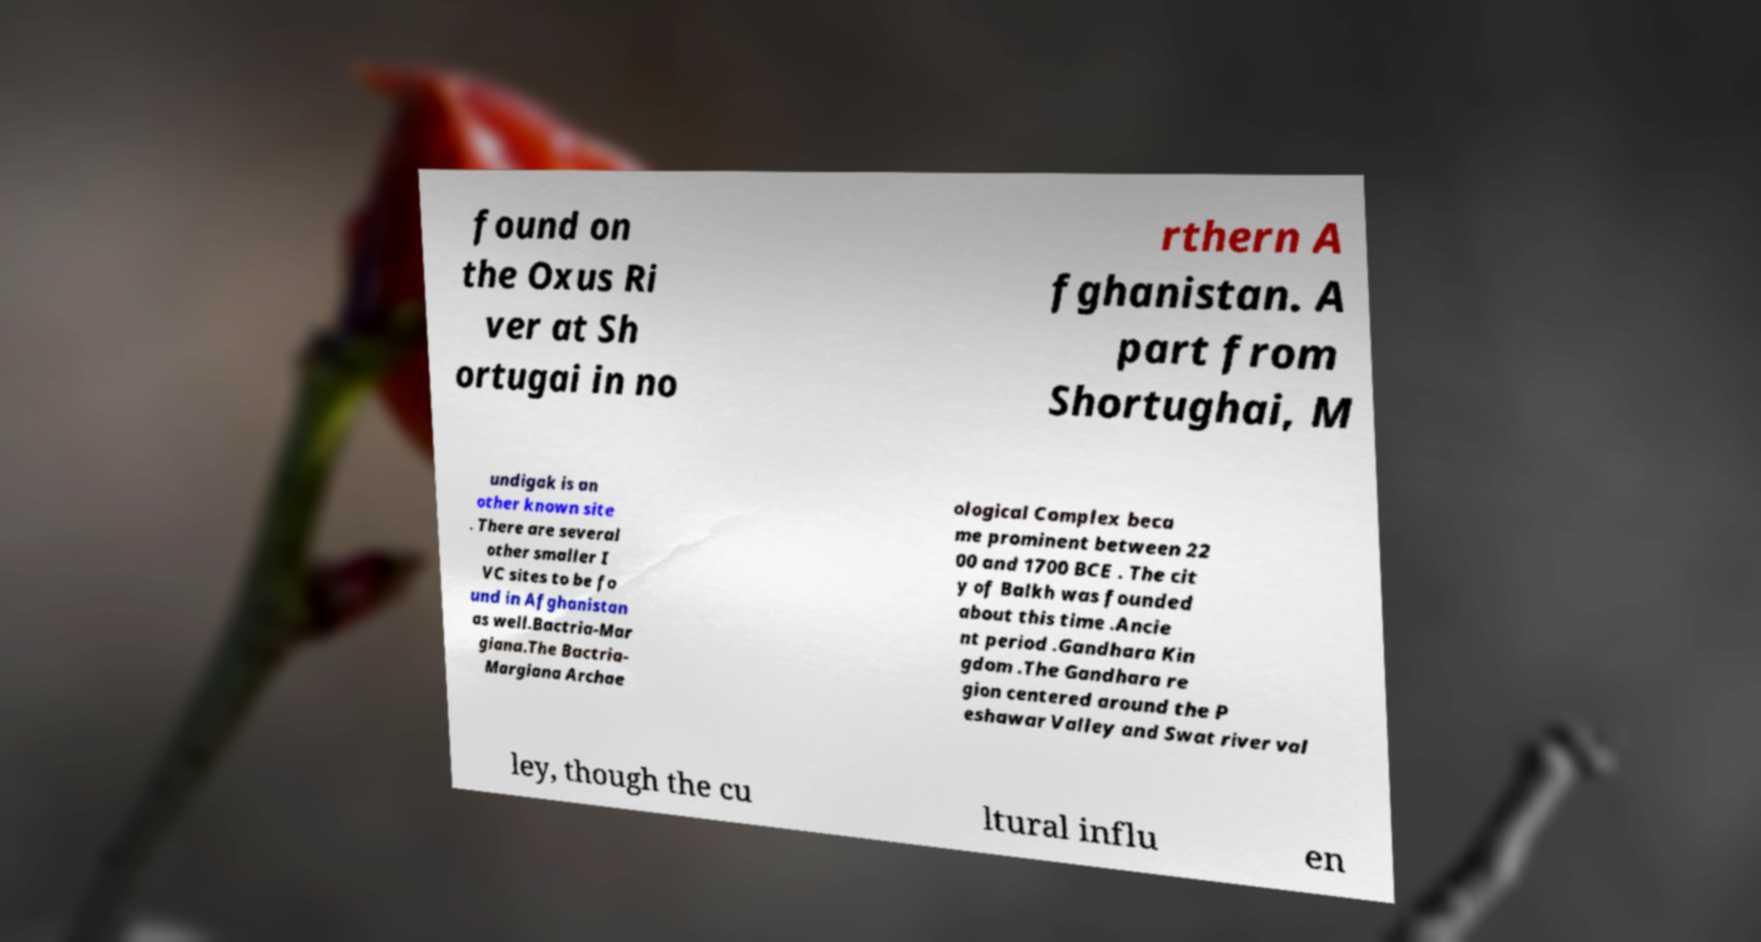What messages or text are displayed in this image? I need them in a readable, typed format. found on the Oxus Ri ver at Sh ortugai in no rthern A fghanistan. A part from Shortughai, M undigak is an other known site . There are several other smaller I VC sites to be fo und in Afghanistan as well.Bactria-Mar giana.The Bactria- Margiana Archae ological Complex beca me prominent between 22 00 and 1700 BCE . The cit y of Balkh was founded about this time .Ancie nt period .Gandhara Kin gdom .The Gandhara re gion centered around the P eshawar Valley and Swat river val ley, though the cu ltural influ en 